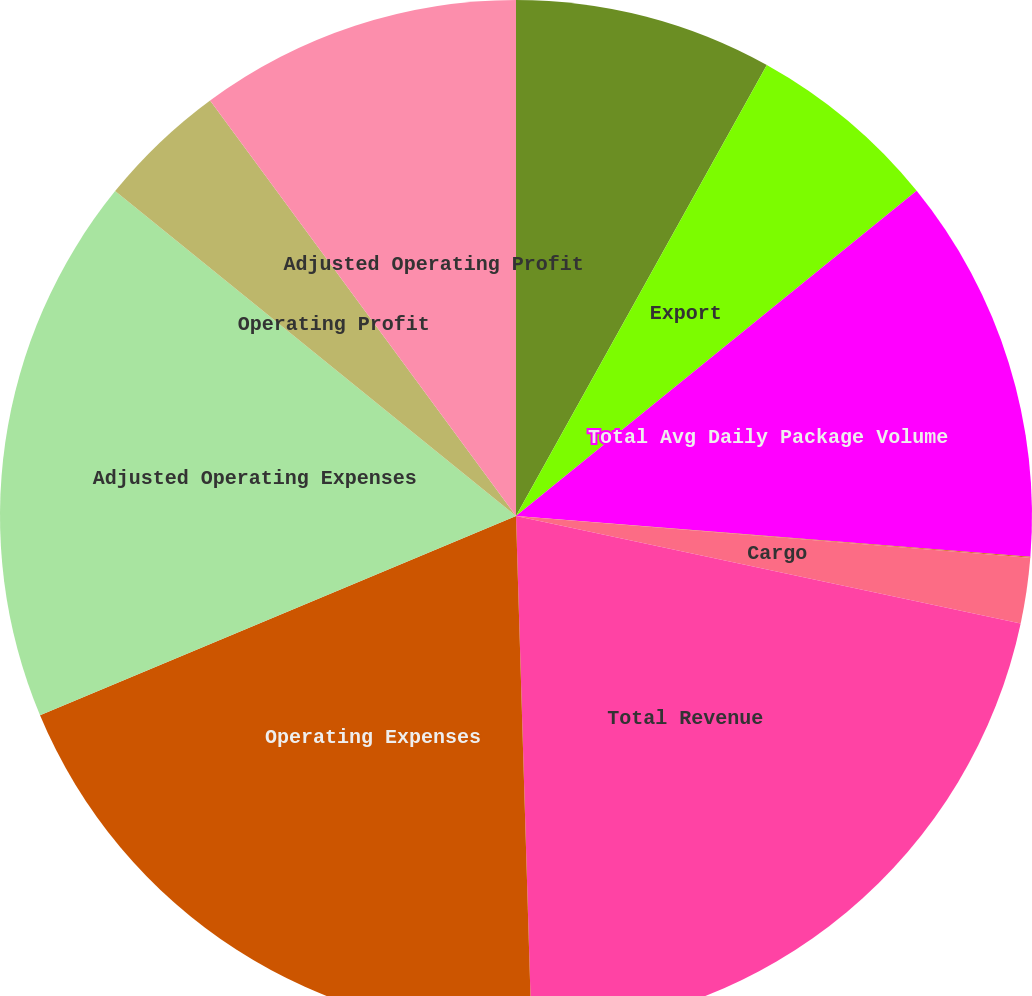<chart> <loc_0><loc_0><loc_500><loc_500><pie_chart><fcel>Domestic<fcel>Export<fcel>Total Avg Daily Package Volume<fcel>Total Avg Revenue Per Piece<fcel>Cargo<fcel>Total Revenue<fcel>Operating Expenses<fcel>Adjusted Operating Expenses<fcel>Operating Profit<fcel>Adjusted Operating Profit<nl><fcel>8.08%<fcel>6.07%<fcel>12.11%<fcel>0.03%<fcel>2.05%<fcel>21.18%<fcel>19.17%<fcel>17.15%<fcel>4.06%<fcel>10.1%<nl></chart> 